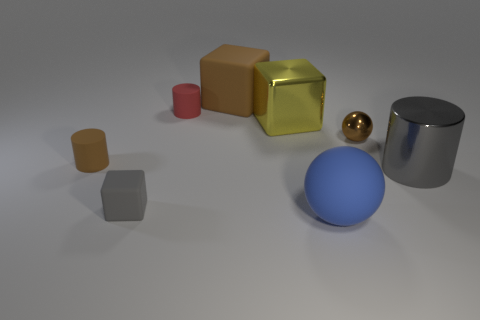Add 1 metallic objects. How many objects exist? 9 Subtract all cylinders. How many objects are left? 5 Subtract 0 yellow balls. How many objects are left? 8 Subtract all brown metal cubes. Subtract all big objects. How many objects are left? 4 Add 8 yellow metal things. How many yellow metal things are left? 9 Add 2 red matte things. How many red matte things exist? 3 